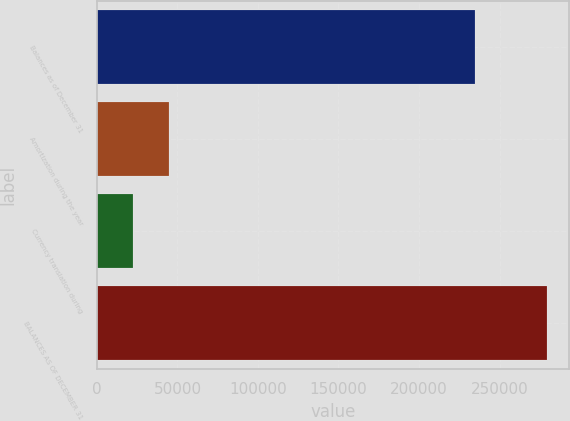Convert chart to OTSL. <chart><loc_0><loc_0><loc_500><loc_500><bar_chart><fcel>Balances as of December 31<fcel>Amortization during the year<fcel>Currency translation during<fcel>BALANCES AS OF DECEMBER 31<nl><fcel>234835<fcel>44765<fcel>22558<fcel>279249<nl></chart> 